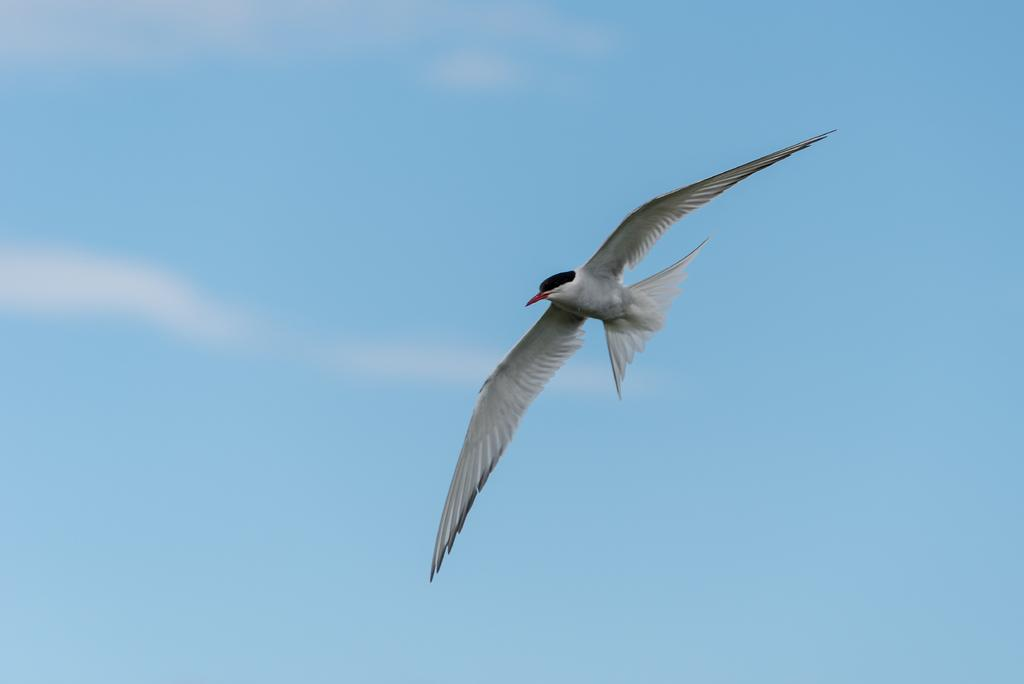What type of animal can be seen in the image? There is a bird in the image. What is the bird doing in the image? The bird is flying in the sky. Where is the battle taking place in the image? There is no battle present in the image; it features a bird flying in the sky. What type of drain can be seen in the image? There is no drain present in the image; it features a bird flying in the sky. 